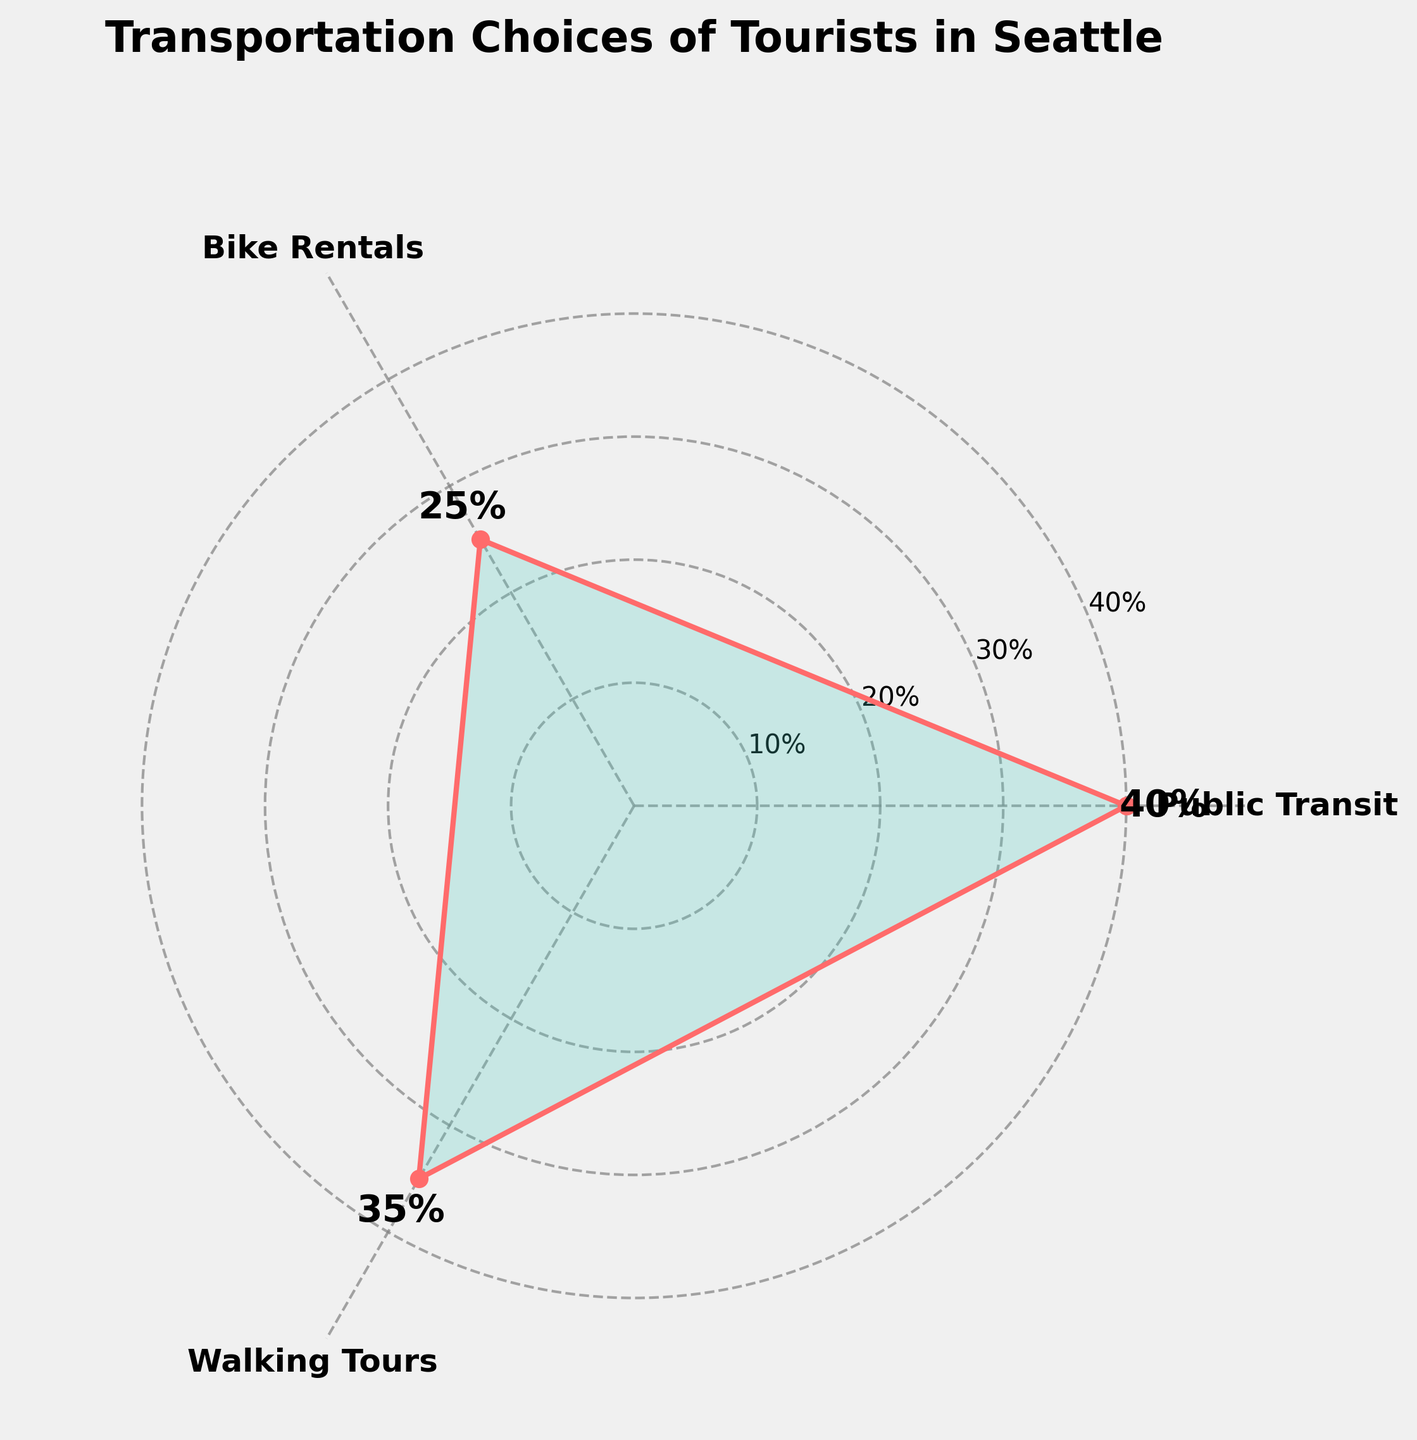What's the title of the chart? The title is located at the top center of the chart and reads "Transportation Choices of Tourists in Seattle".
Answer: Transportation Choices of Tourists in Seattle What are the categories shown in the chart? The categories are shown as labels on the outer ring of the rose chart in the areas where the lines intersect the outer edge. They are Public Transit, Bike Rentals, and Walking Tours.
Answer: Public Transit, Bike Rentals, Walking Tours Which category has the highest share? The category with the highest share is indicated by the segment that extends farthest from the center of the chart. Comparing all, Public Transit is the longest.
Answer: Public Transit What is the share percentage for Bike Rentals? The share percentage for Bike Rentals is marked next to the corresponding segment on the chart. There is an annotation next to the Bike Rentals segment that marks it as 25%.
Answer: 25% What is the sum of the shares for Public Transit and Walking Tours? First, find the share for Public Transit (40%) and Walking Tours (35%). Add them together: 40% + 35% = 75%.
Answer: 75% Which category has the smallest share? The category with the smallest share is indicated by the segment closest to the center. Comparing all segments, Bike Rentals is the shortest.
Answer: Bike Rentals By how much does the share of Walking Tours exceed that of Bike Rentals? The share of Walking Tours is 35%, and the share of Bike Rentals is 25%. Subtract the Bike Rentals share from the Walking Tours share: 35% - 25% = 10%.
Answer: 10% How are the values annotated on the chart? The values are displayed next to each segment's corresponding category, slightly outside the edge of the rose chart. The segments are marked with percentages: 40% next to Public Transit, 35% next to Walking Tours, and 25% next to Bike Rentals.
Answer: Percentages next to segment labels What logistical information does the radial axis provide? The radial axis indicates the percentage share in intervals of 10% (10%, 20%, 30%, and 40%). It gives an idea of the magnitude of each category's share in the chart.
Answer: Interval percentages (10%, 20%, 30%, 40%) Is the share of Public Transit more than the combined share of Bike Rentals and Walking Tours? The share of Public Transit is 40%. The combined share of Bike Rentals (25%) and Walking Tours (35%) is 25% + 35% = 60%. Since 40% < 60%, the share of Public Transit is not more.
Answer: No 